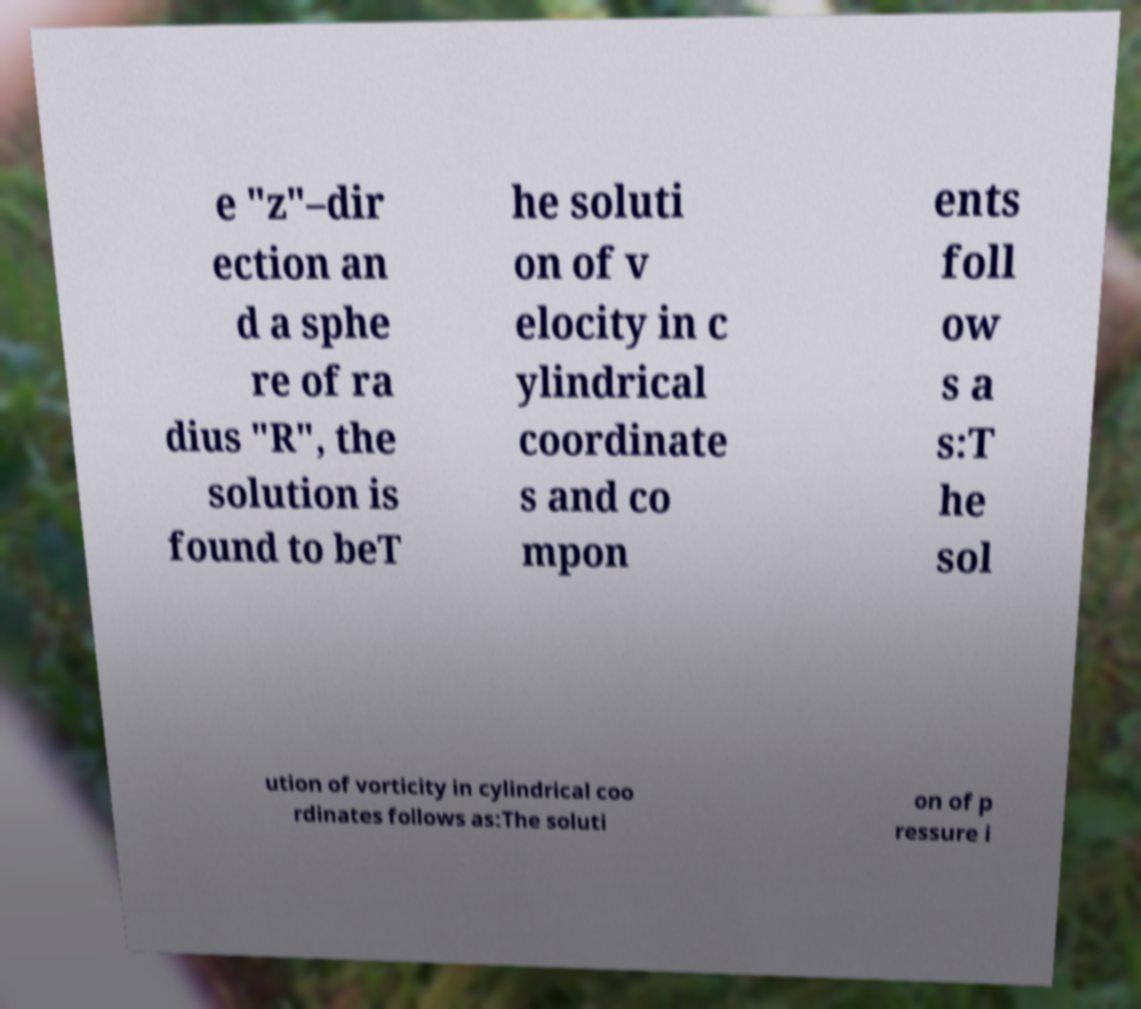Please identify and transcribe the text found in this image. e "z"–dir ection an d a sphe re of ra dius "R", the solution is found to beT he soluti on of v elocity in c ylindrical coordinate s and co mpon ents foll ow s a s:T he sol ution of vorticity in cylindrical coo rdinates follows as:The soluti on of p ressure i 